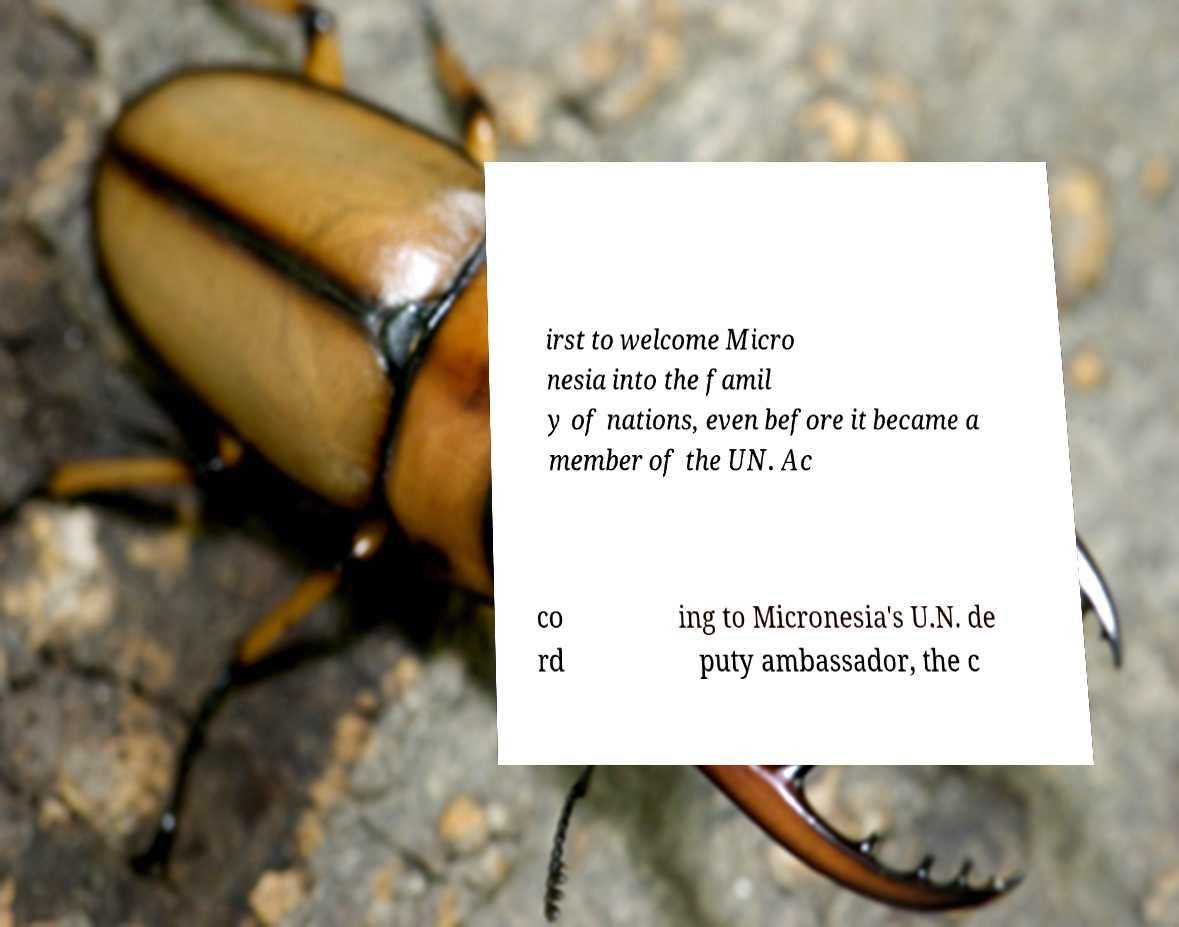For documentation purposes, I need the text within this image transcribed. Could you provide that? irst to welcome Micro nesia into the famil y of nations, even before it became a member of the UN. Ac co rd ing to Micronesia's U.N. de puty ambassador, the c 